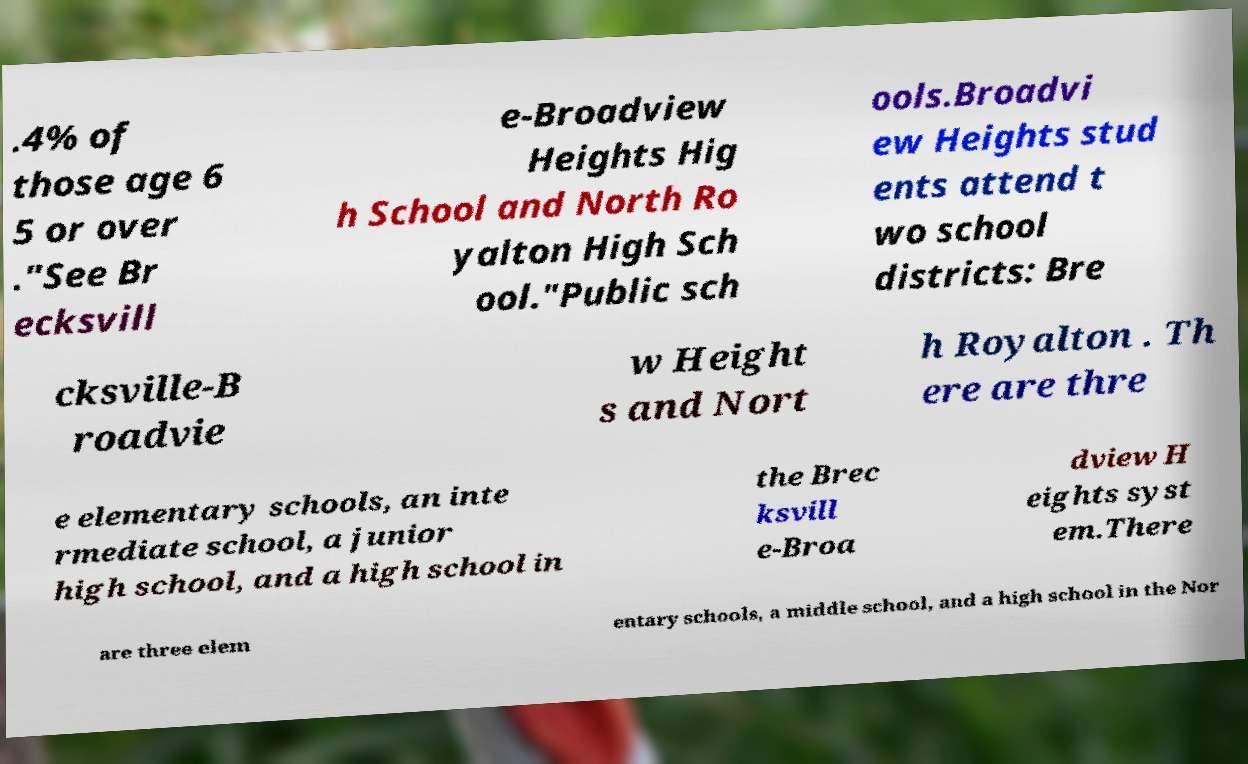I need the written content from this picture converted into text. Can you do that? .4% of those age 6 5 or over ."See Br ecksvill e-Broadview Heights Hig h School and North Ro yalton High Sch ool."Public sch ools.Broadvi ew Heights stud ents attend t wo school districts: Bre cksville-B roadvie w Height s and Nort h Royalton . Th ere are thre e elementary schools, an inte rmediate school, a junior high school, and a high school in the Brec ksvill e-Broa dview H eights syst em.There are three elem entary schools, a middle school, and a high school in the Nor 